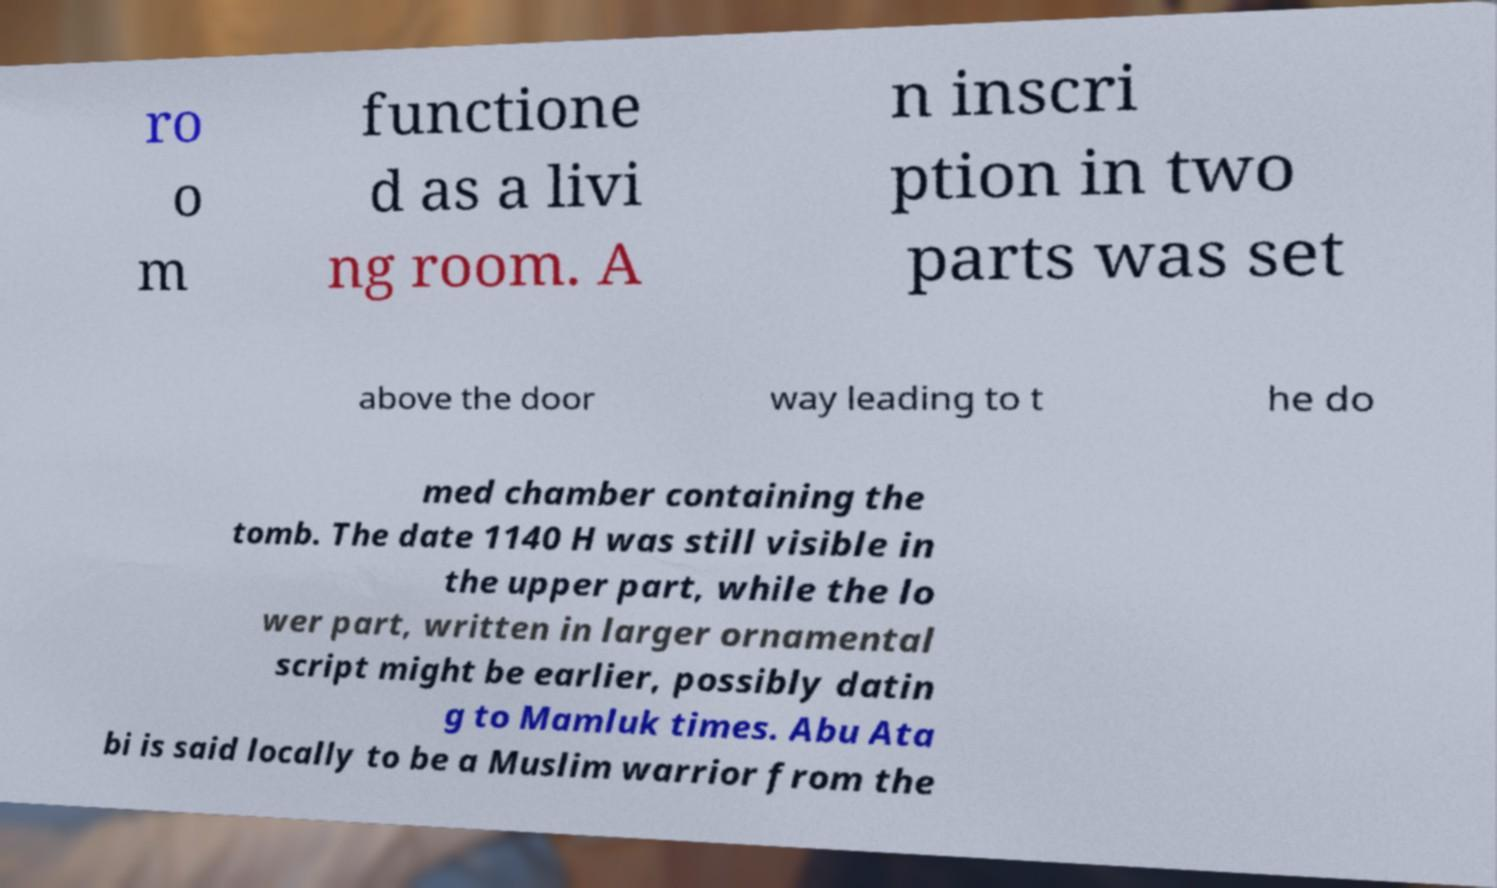For documentation purposes, I need the text within this image transcribed. Could you provide that? ro o m functione d as a livi ng room. A n inscri ption in two parts was set above the door way leading to t he do med chamber containing the tomb. The date 1140 H was still visible in the upper part, while the lo wer part, written in larger ornamental script might be earlier, possibly datin g to Mamluk times. Abu Ata bi is said locally to be a Muslim warrior from the 